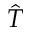<formula> <loc_0><loc_0><loc_500><loc_500>\hat { T }</formula> 